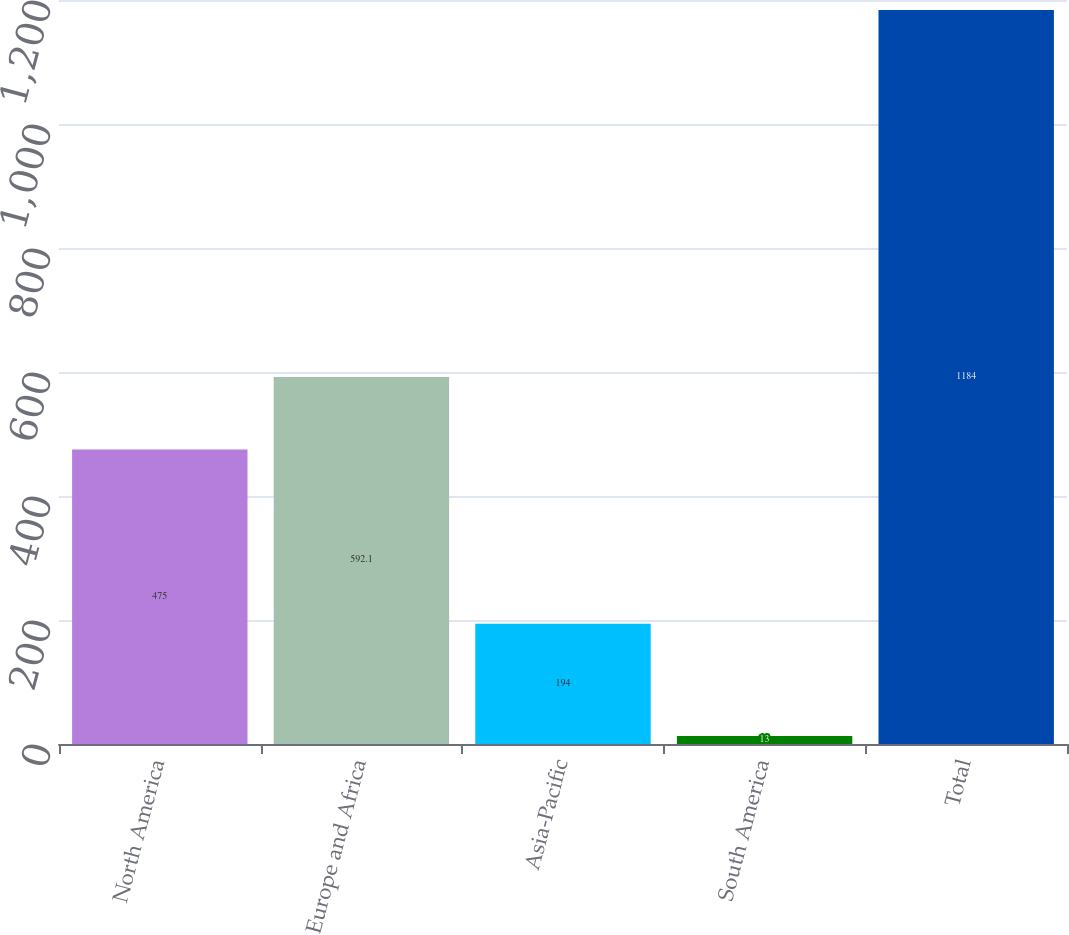Convert chart to OTSL. <chart><loc_0><loc_0><loc_500><loc_500><bar_chart><fcel>North America<fcel>Europe and Africa<fcel>Asia-Pacific<fcel>South America<fcel>Total<nl><fcel>475<fcel>592.1<fcel>194<fcel>13<fcel>1184<nl></chart> 